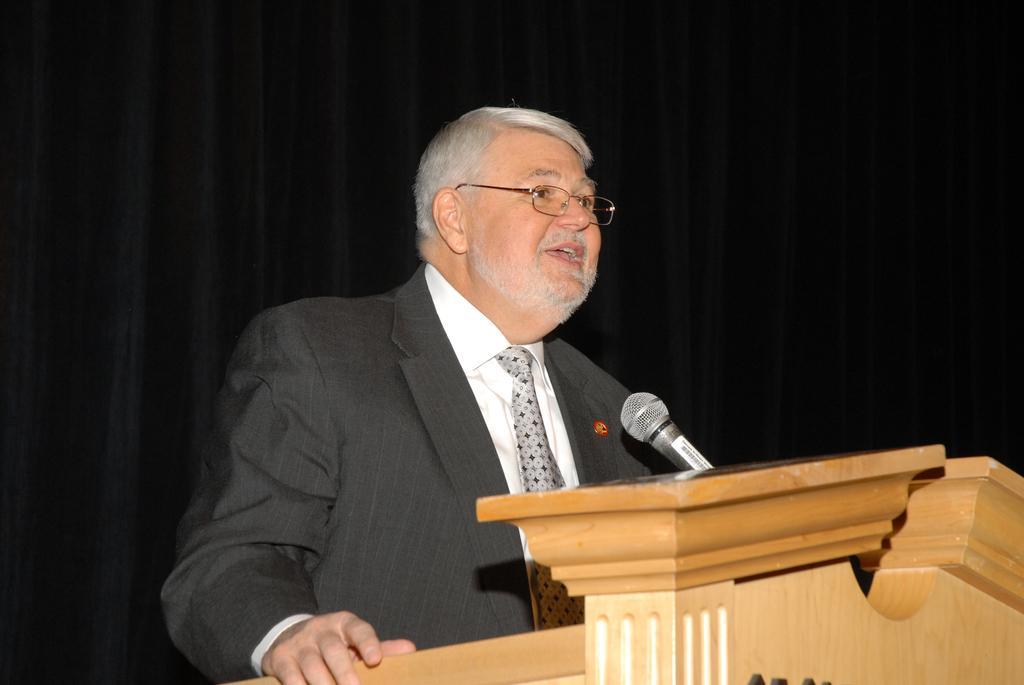Please provide a concise description of this image. Here we see a man standing at a podium and speaking with the help of a microphone. 